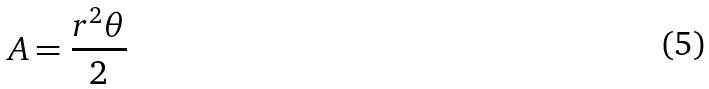<formula> <loc_0><loc_0><loc_500><loc_500>A = \frac { r ^ { 2 } \theta } { 2 }</formula> 